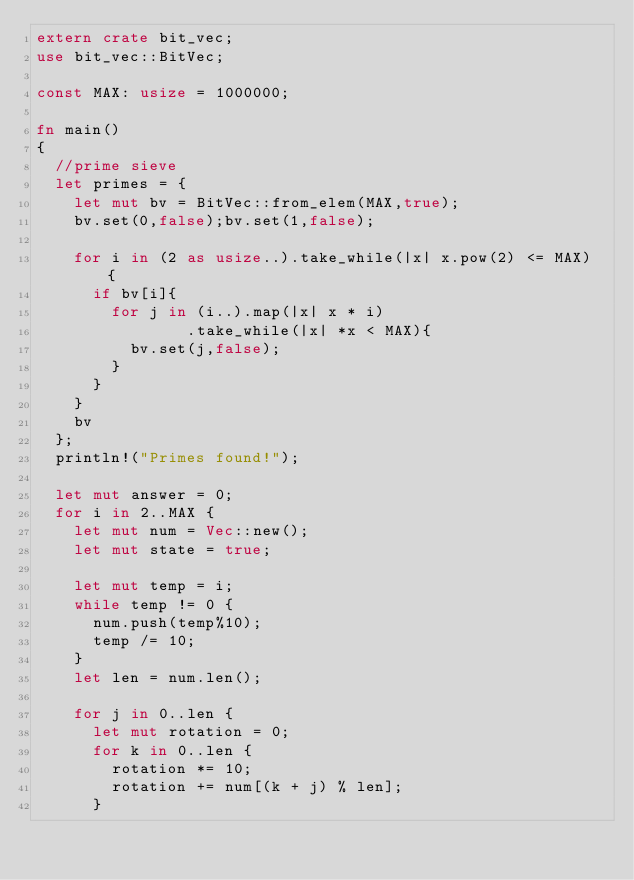Convert code to text. <code><loc_0><loc_0><loc_500><loc_500><_Rust_>extern crate bit_vec;
use bit_vec::BitVec;

const MAX: usize = 1000000;

fn main()
{
	//prime sieve
	let primes = {
		let mut bv = BitVec::from_elem(MAX,true);
		bv.set(0,false);bv.set(1,false);

		for i in (2 as usize..).take_while(|x| x.pow(2) <= MAX) {
			if bv[i]{
				for j in (i..).map(|x| x * i)
							  .take_while(|x| *x < MAX){
					bv.set(j,false);
				}
			}
		}
		bv
	};
	println!("Primes found!");

	let mut answer = 0;
	for i in 2..MAX {
		let mut num = Vec::new();
		let mut state = true;

		let mut temp = i;
		while temp != 0 {
			num.push(temp%10);
			temp /= 10;
		}
		let len = num.len();

		for j in 0..len {
			let mut rotation = 0;
			for k in 0..len {
				rotation *= 10;
				rotation += num[(k + j) % len];
			}</code> 